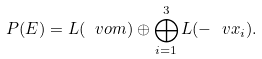Convert formula to latex. <formula><loc_0><loc_0><loc_500><loc_500>P ( E ) = L ( \ v o m ) \oplus \bigoplus _ { i = 1 } ^ { 3 } L ( - \ v x _ { i } ) .</formula> 